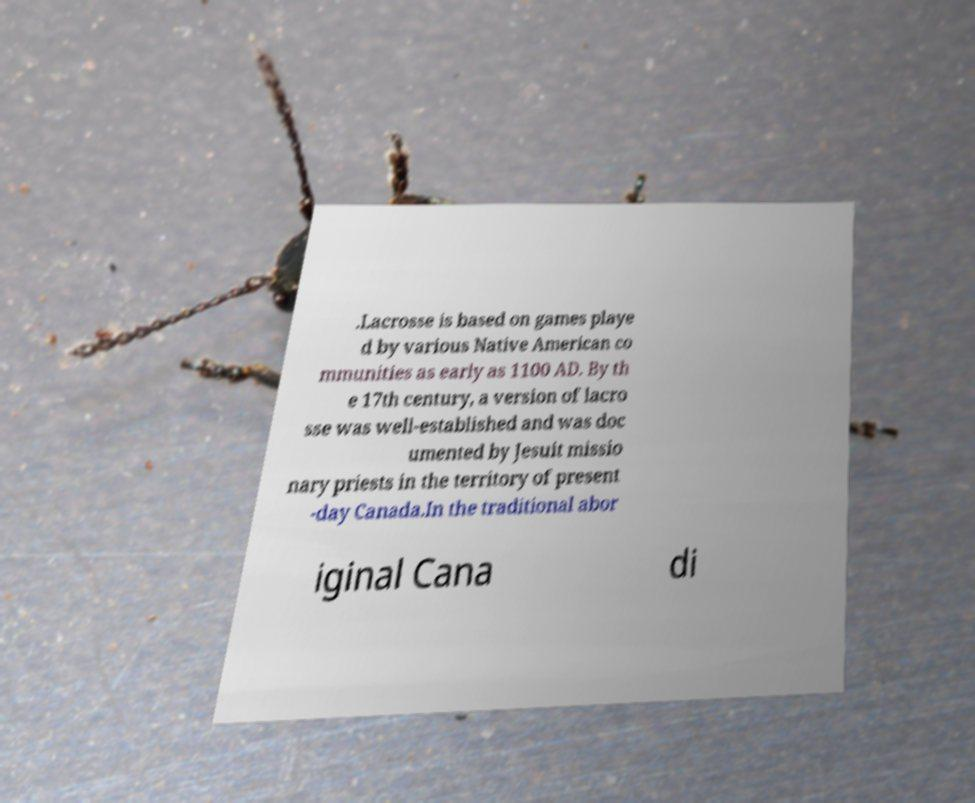For documentation purposes, I need the text within this image transcribed. Could you provide that? .Lacrosse is based on games playe d by various Native American co mmunities as early as 1100 AD. By th e 17th century, a version of lacro sse was well-established and was doc umented by Jesuit missio nary priests in the territory of present -day Canada.In the traditional abor iginal Cana di 